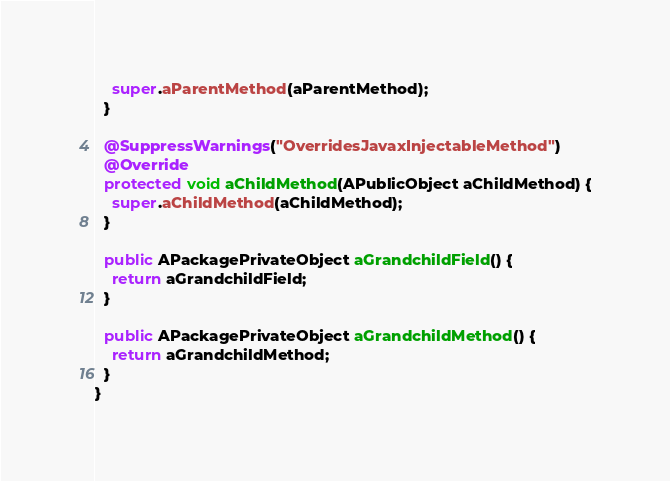<code> <loc_0><loc_0><loc_500><loc_500><_Java_>    super.aParentMethod(aParentMethod);
  }

  @SuppressWarnings("OverridesJavaxInjectableMethod")
  @Override
  protected void aChildMethod(APublicObject aChildMethod) {
    super.aChildMethod(aChildMethod);
  }

  public APackagePrivateObject aGrandchildField() {
    return aGrandchildField;
  }

  public APackagePrivateObject aGrandchildMethod() {
    return aGrandchildMethod;
  }
}
</code> 